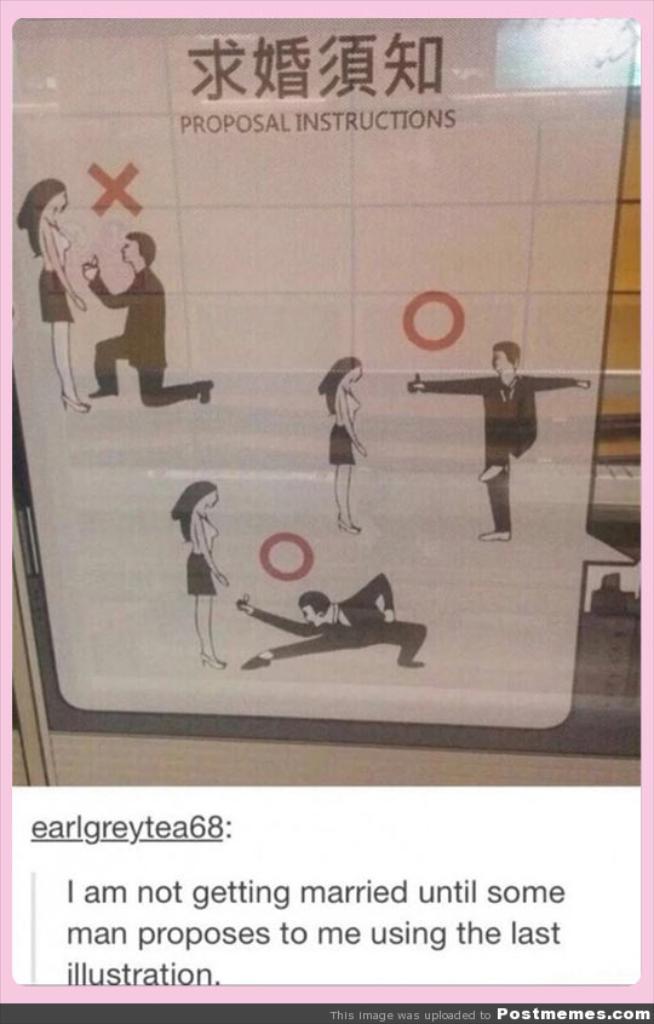<image>
Provide a brief description of the given image. A sign titled Proposal Instructions showing illustrations of how a man should propose marriage. 